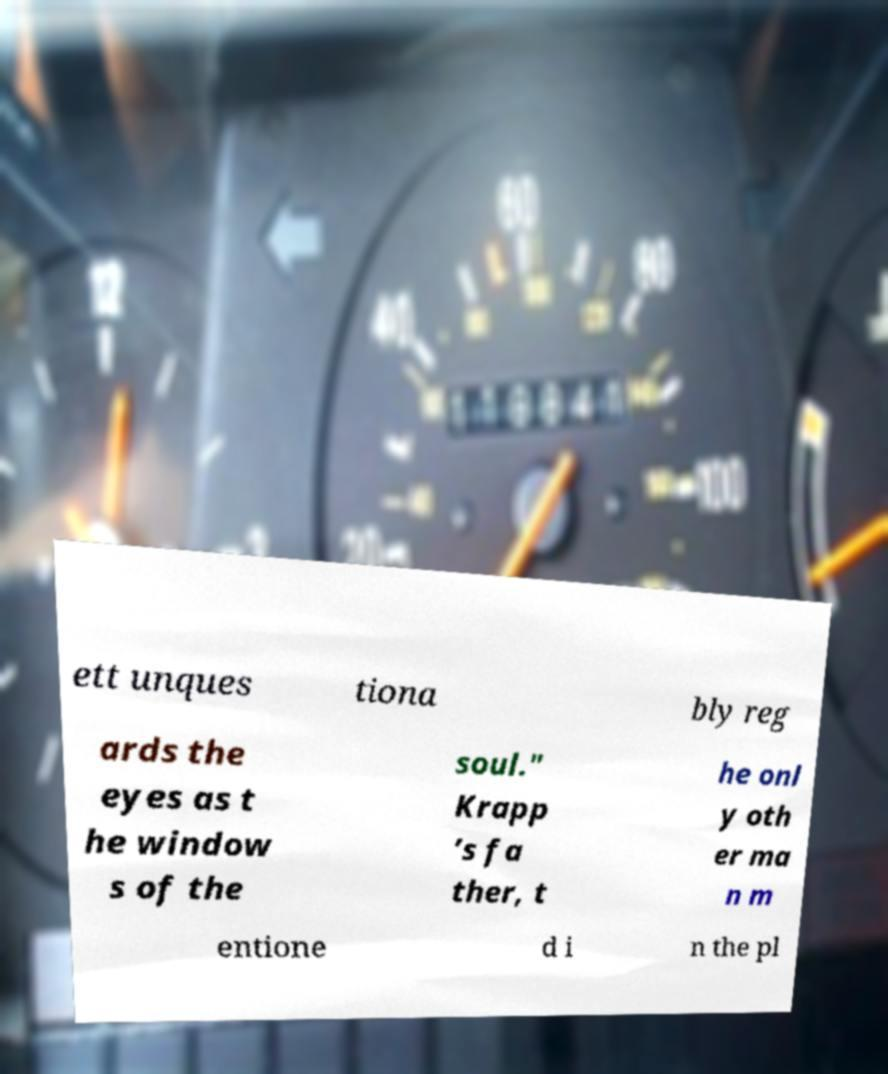Can you read and provide the text displayed in the image?This photo seems to have some interesting text. Can you extract and type it out for me? ett unques tiona bly reg ards the eyes as t he window s of the soul." Krapp ’s fa ther, t he onl y oth er ma n m entione d i n the pl 